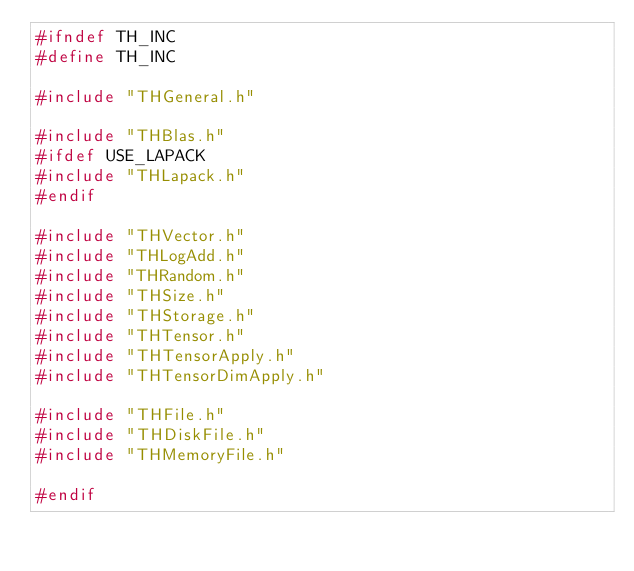<code> <loc_0><loc_0><loc_500><loc_500><_C_>#ifndef TH_INC
#define TH_INC

#include "THGeneral.h"

#include "THBlas.h"
#ifdef USE_LAPACK
#include "THLapack.h"
#endif

#include "THVector.h"
#include "THLogAdd.h"
#include "THRandom.h"
#include "THSize.h"
#include "THStorage.h"
#include "THTensor.h"
#include "THTensorApply.h"
#include "THTensorDimApply.h"

#include "THFile.h"
#include "THDiskFile.h"
#include "THMemoryFile.h"

#endif
</code> 